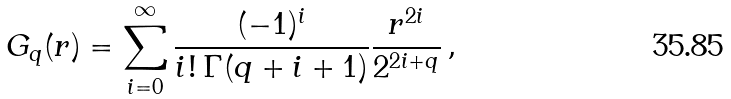Convert formula to latex. <formula><loc_0><loc_0><loc_500><loc_500>G _ { q } ( r ) = \sum _ { i = 0 } ^ { \infty } \frac { ( - 1 ) ^ { i } } { i ! \, \Gamma ( q + i + 1 ) } \frac { r ^ { 2 i } } { 2 ^ { 2 i + q } } \, ,</formula> 